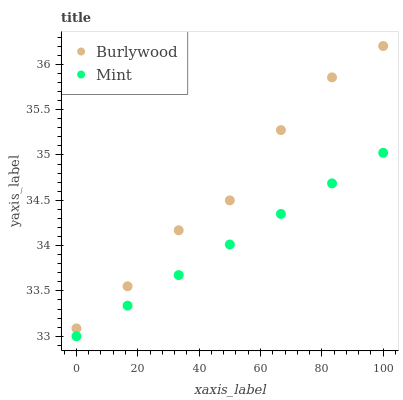Does Mint have the minimum area under the curve?
Answer yes or no. Yes. Does Burlywood have the maximum area under the curve?
Answer yes or no. Yes. Does Mint have the maximum area under the curve?
Answer yes or no. No. Is Mint the smoothest?
Answer yes or no. Yes. Is Burlywood the roughest?
Answer yes or no. Yes. Is Mint the roughest?
Answer yes or no. No. Does Mint have the lowest value?
Answer yes or no. Yes. Does Burlywood have the highest value?
Answer yes or no. Yes. Does Mint have the highest value?
Answer yes or no. No. Is Mint less than Burlywood?
Answer yes or no. Yes. Is Burlywood greater than Mint?
Answer yes or no. Yes. Does Mint intersect Burlywood?
Answer yes or no. No. 